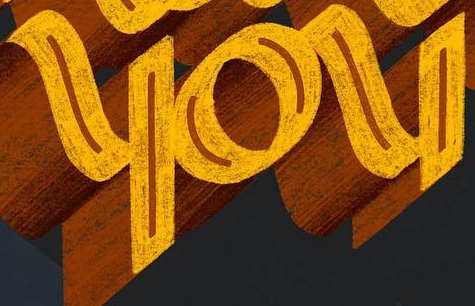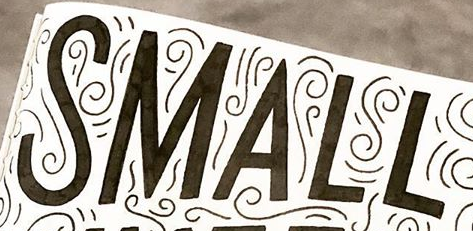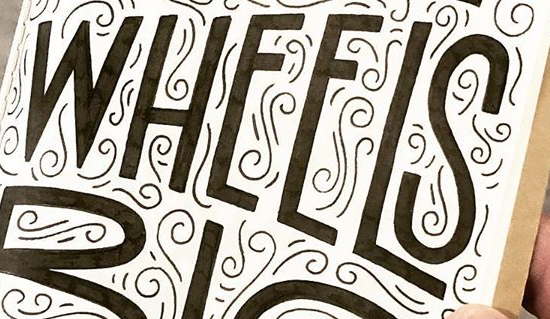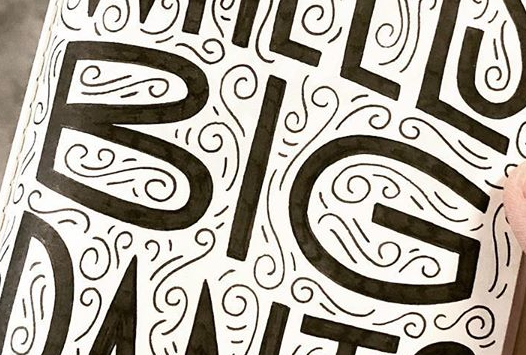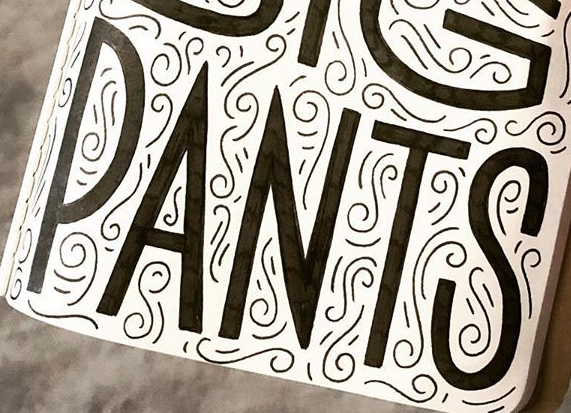What text is displayed in these images sequentially, separated by a semicolon? you; SMALL; WHEELS; BIG; PANTS 